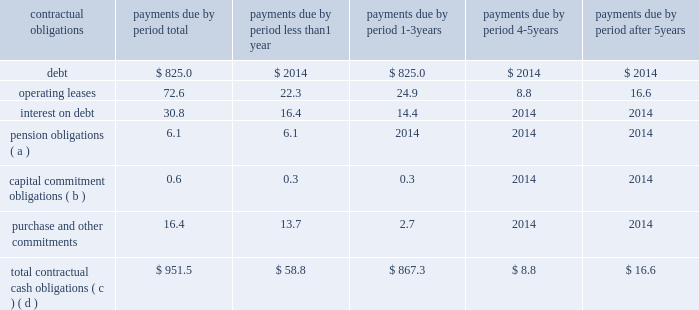Net cash flows provided by operating activities of $ 704.4 million for 2016 increased $ 154.7 million from 2015 due primarily to ( 1 ) improved operating performance and ( 2 ) lower supplier payments in 2016 compared to 2015 , partially offset by ( 1 ) the impact of excess tax benefits from stock plans , primarily due to our increased stock price , and ( 2 ) an increase in accounts receivable due to increased sales , primarily in the united states .
Net cash flows provided by operating activities of $ 549.7 million for 2015 decreased $ 472.6 million from 2014 due primarily to ( 1 ) the $ 750.0 million upfront payment received from medtronic under a litigation settlement agreement , and ( 2 ) a higher bonus payout in 2015 associated with 2014 performance .
These decreases were partially offset by ( 1 ) income tax payments of $ 224.5 million made in 2014 related to the medtronic settlement , ( 2 ) improved operating performance in 2015 , and ( 3 ) the $ 50.0 million charitable contribution made in 2014 to the edwards lifesciences foundation .
Net cash used in investing activities of $ 211.7 million in 2016 consisted primarily of capital expenditures of $ 176.1 million and $ 41.3 million for the acquisition of intangible assets .
Net cash used in investing activities of $ 316.1 million in 2015 consisted primarily of a $ 320.1 million net payment associated with the acquisition of cardiaq , and capital expenditures of $ 102.7 million , partially offset by net proceeds from investments of $ 119.6 million .
Net cash used in investing activities of $ 633.0 million in 2014 consisted primarily of net purchases of investments of $ 527.4 million and capital expenditures of $ 82.9 million .
Net cash used in financing activities of $ 268.5 million in 2016 consisted primarily of purchases of treasury stock of $ 662.3 million , partially offset by ( 1 ) net proceeds from the issuance of debt of $ 222.1 million , ( 2 ) proceeds from stock plans of $ 103.3 million , and ( 3 ) the excess tax benefit from stock plans of $ 64.3 million .
Net cash used in financing activities of $ 158.6 million in 2015 consisted primarily of purchases of treasury stock of $ 280.1 million , partially offset by ( 1 ) proceeds from stock plans of $ 87.2 million , and ( 2 ) the excess tax benefit from stock plans of $ 41.3 million .
Net cash used in financing activities of $ 153.0 million in 2014 consisted primarily of purchases of treasury stock of $ 300.9 million , partially offset by ( 1 ) proceeds from stock plans of $ 113.3 million , and ( 2 ) the excess tax benefit from stock plans of $ 49.4 million ( including the realization of previously unrealized excess tax benefits ) .
A summary of all of our contractual obligations and commercial commitments as of december 31 , 2016 were as follows ( in millions ) : .
( a ) the amount included in 2018 2018less than 1 year 2019 2019 reflects anticipated contributions to our various pension plans .
Anticipated contributions beyond one year are not determinable .
The total accrued benefit liability for our pension plans recognized as of december 31 , 2016 was $ 50.1 million .
This amount is impacted .
What percentage of total contractual cash obligations is debt? 
Computations: (825.0 / 951.5)
Answer: 0.86705. 